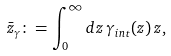<formula> <loc_0><loc_0><loc_500><loc_500>\bar { z } _ { \gamma } \colon = \int _ { 0 } ^ { \infty } d z \, \gamma _ { i n t } ( z ) \, z ,</formula> 